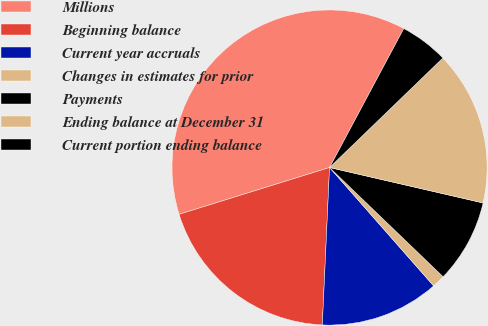<chart> <loc_0><loc_0><loc_500><loc_500><pie_chart><fcel>Millions<fcel>Beginning balance<fcel>Current year accruals<fcel>Changes in estimates for prior<fcel>Payments<fcel>Ending balance at December 31<fcel>Current portion ending balance<nl><fcel>37.61%<fcel>19.47%<fcel>12.21%<fcel>1.33%<fcel>8.58%<fcel>15.84%<fcel>4.96%<nl></chart> 